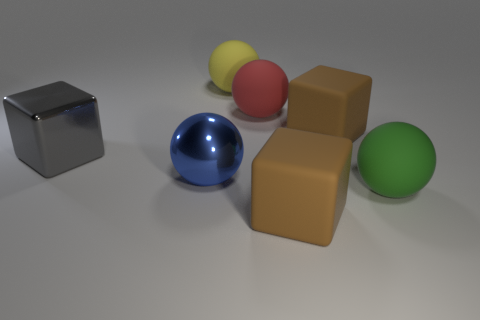Can you name the colors of the objects seen in the image? Certainly! The objects display a variety of colors: there's a silver cube, a blue sphere, a red sphere, a yellow sphere, two brown cubes, and a green sphere. 